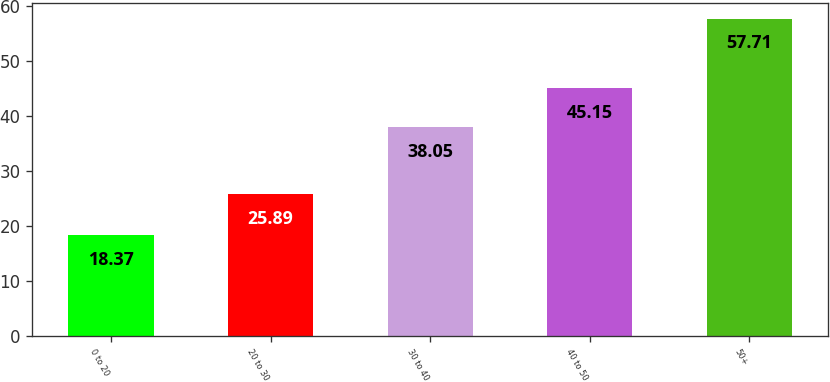Convert chart to OTSL. <chart><loc_0><loc_0><loc_500><loc_500><bar_chart><fcel>0 to 20<fcel>20 to 30<fcel>30 to 40<fcel>40 to 50<fcel>50+<nl><fcel>18.37<fcel>25.89<fcel>38.05<fcel>45.15<fcel>57.71<nl></chart> 